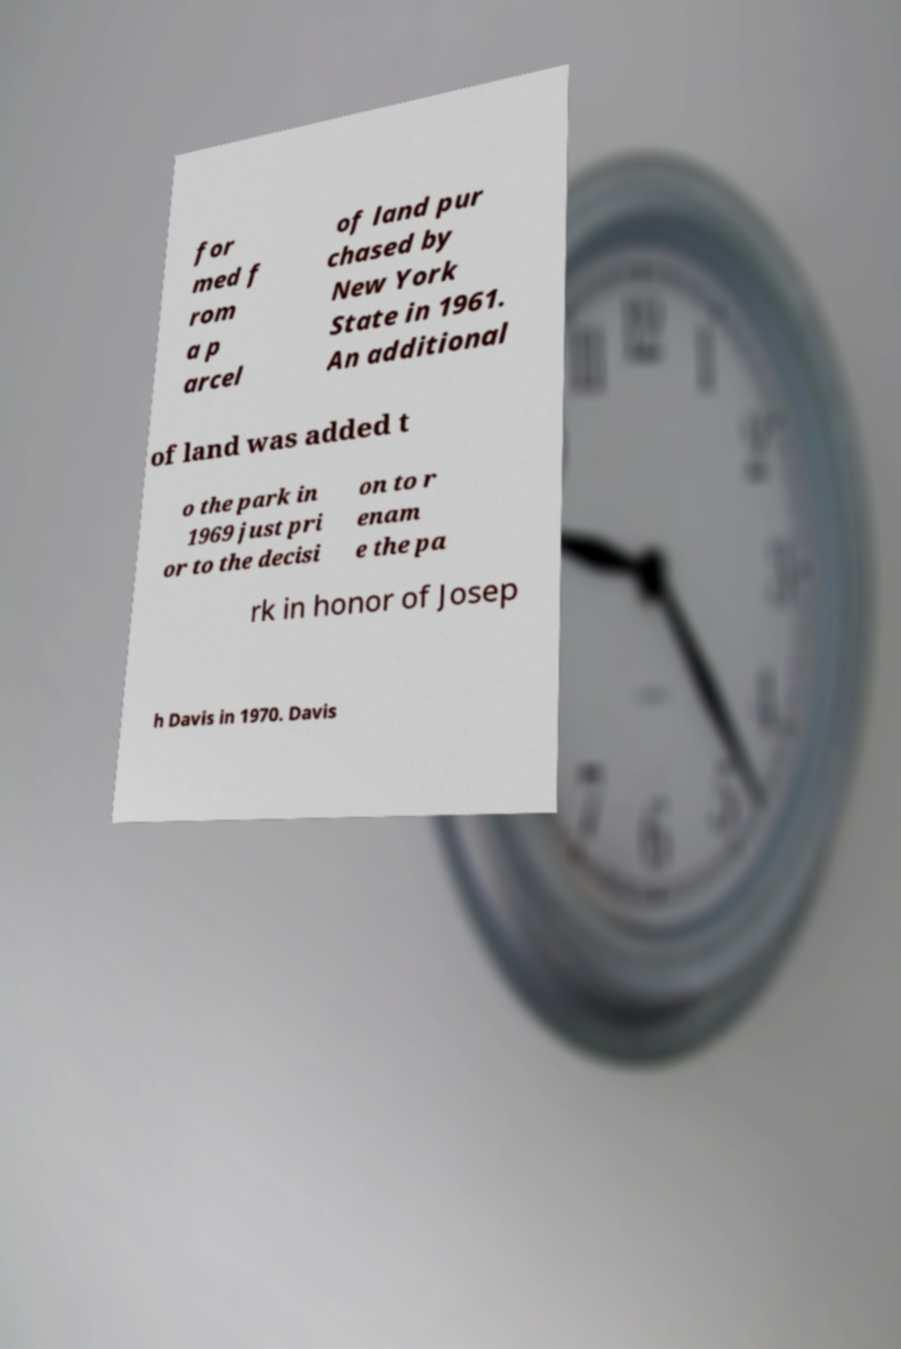Please read and relay the text visible in this image. What does it say? for med f rom a p arcel of land pur chased by New York State in 1961. An additional of land was added t o the park in 1969 just pri or to the decisi on to r enam e the pa rk in honor of Josep h Davis in 1970. Davis 